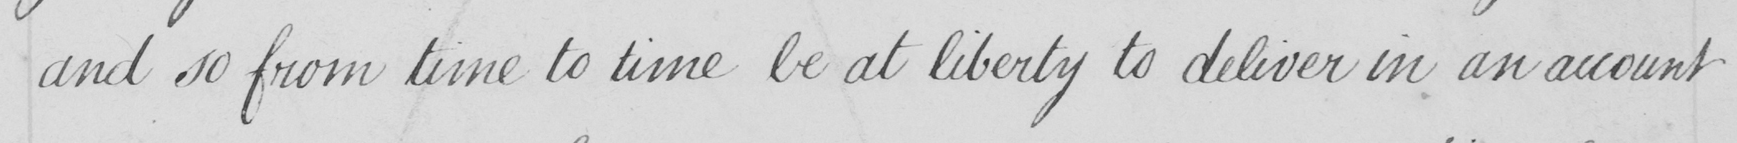Can you read and transcribe this handwriting? and so from time to time be at liberty to deliver in an account 